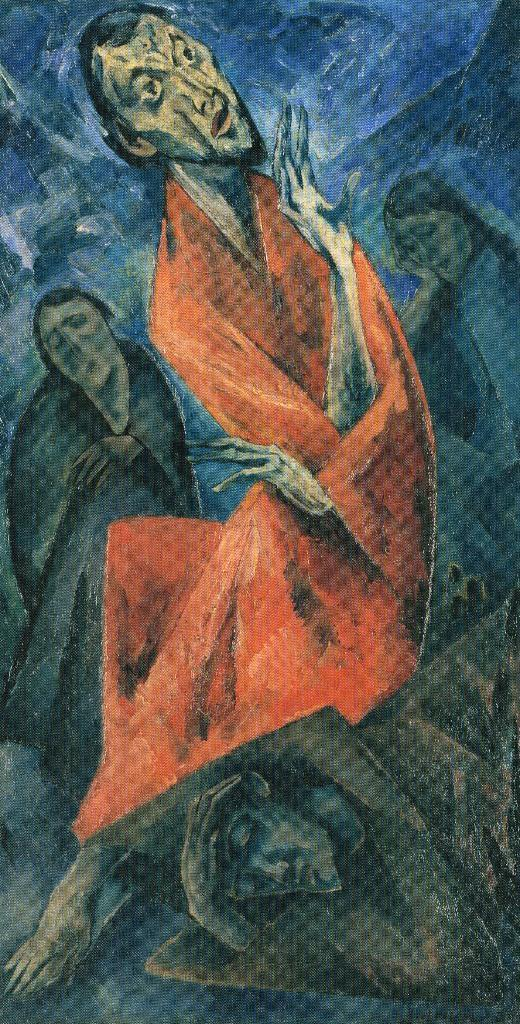What is the main subject in the image? There is a painted board in the image. What is depicted on the painted board? The painted board contains an image that looks like a person. Can you tell me how many pickles are present on the painted board? There are no pickles present on the painted board; it contains an image that looks like a person. What is the comparison between the painted board and a real person? The painted board is not a real person, but rather an image on a painted board. 